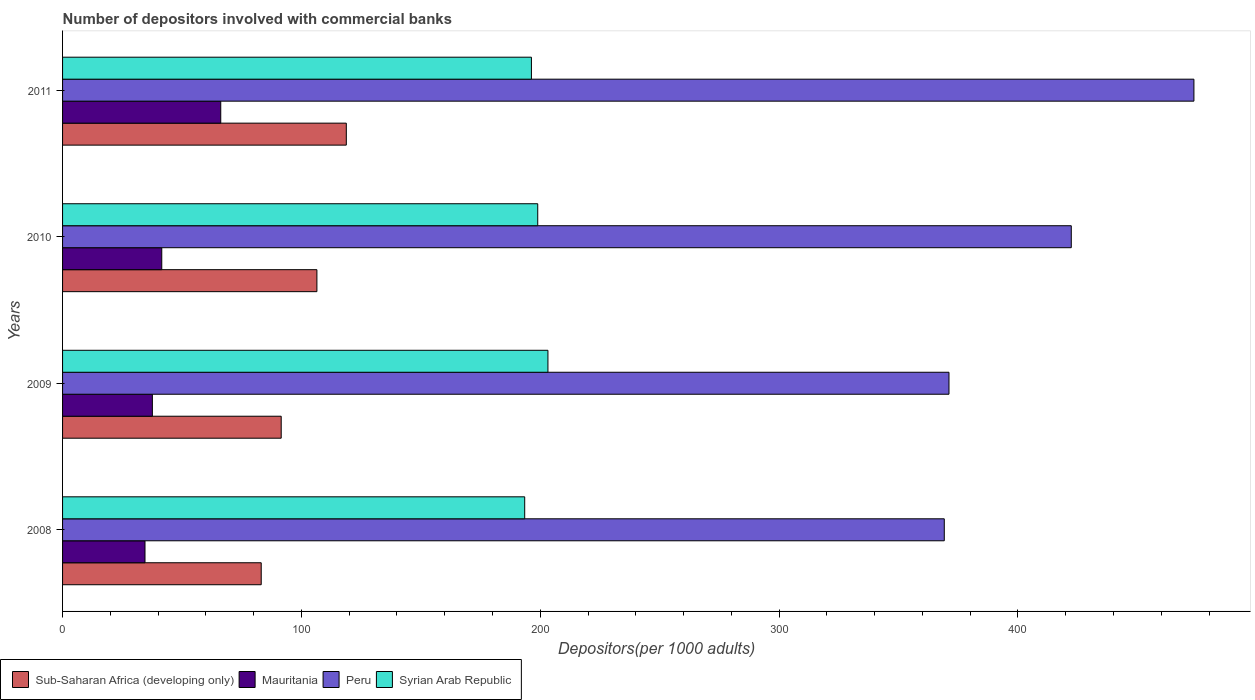In how many cases, is the number of bars for a given year not equal to the number of legend labels?
Ensure brevity in your answer.  0. What is the number of depositors involved with commercial banks in Sub-Saharan Africa (developing only) in 2009?
Make the answer very short. 91.54. Across all years, what is the maximum number of depositors involved with commercial banks in Syrian Arab Republic?
Offer a very short reply. 203.22. Across all years, what is the minimum number of depositors involved with commercial banks in Sub-Saharan Africa (developing only)?
Offer a very short reply. 83.18. In which year was the number of depositors involved with commercial banks in Peru maximum?
Provide a short and direct response. 2011. In which year was the number of depositors involved with commercial banks in Peru minimum?
Provide a succinct answer. 2008. What is the total number of depositors involved with commercial banks in Mauritania in the graph?
Make the answer very short. 179.89. What is the difference between the number of depositors involved with commercial banks in Syrian Arab Republic in 2008 and that in 2010?
Offer a very short reply. -5.46. What is the difference between the number of depositors involved with commercial banks in Mauritania in 2010 and the number of depositors involved with commercial banks in Syrian Arab Republic in 2011?
Make the answer very short. -154.77. What is the average number of depositors involved with commercial banks in Sub-Saharan Africa (developing only) per year?
Provide a short and direct response. 100. In the year 2011, what is the difference between the number of depositors involved with commercial banks in Syrian Arab Republic and number of depositors involved with commercial banks in Sub-Saharan Africa (developing only)?
Make the answer very short. 77.5. What is the ratio of the number of depositors involved with commercial banks in Sub-Saharan Africa (developing only) in 2009 to that in 2011?
Provide a short and direct response. 0.77. Is the difference between the number of depositors involved with commercial banks in Syrian Arab Republic in 2009 and 2011 greater than the difference between the number of depositors involved with commercial banks in Sub-Saharan Africa (developing only) in 2009 and 2011?
Give a very brief answer. Yes. What is the difference between the highest and the second highest number of depositors involved with commercial banks in Syrian Arab Republic?
Your response must be concise. 4.27. What is the difference between the highest and the lowest number of depositors involved with commercial banks in Sub-Saharan Africa (developing only)?
Provide a short and direct response. 35.63. In how many years, is the number of depositors involved with commercial banks in Mauritania greater than the average number of depositors involved with commercial banks in Mauritania taken over all years?
Offer a terse response. 1. Is the sum of the number of depositors involved with commercial banks in Sub-Saharan Africa (developing only) in 2010 and 2011 greater than the maximum number of depositors involved with commercial banks in Peru across all years?
Your answer should be very brief. No. Is it the case that in every year, the sum of the number of depositors involved with commercial banks in Syrian Arab Republic and number of depositors involved with commercial banks in Mauritania is greater than the sum of number of depositors involved with commercial banks in Sub-Saharan Africa (developing only) and number of depositors involved with commercial banks in Peru?
Your answer should be very brief. Yes. What does the 4th bar from the top in 2010 represents?
Ensure brevity in your answer.  Sub-Saharan Africa (developing only). What does the 2nd bar from the bottom in 2008 represents?
Give a very brief answer. Mauritania. Is it the case that in every year, the sum of the number of depositors involved with commercial banks in Sub-Saharan Africa (developing only) and number of depositors involved with commercial banks in Syrian Arab Republic is greater than the number of depositors involved with commercial banks in Peru?
Give a very brief answer. No. What is the difference between two consecutive major ticks on the X-axis?
Offer a terse response. 100. Are the values on the major ticks of X-axis written in scientific E-notation?
Your answer should be very brief. No. Does the graph contain any zero values?
Provide a short and direct response. No. Does the graph contain grids?
Your answer should be compact. No. How many legend labels are there?
Provide a succinct answer. 4. How are the legend labels stacked?
Make the answer very short. Horizontal. What is the title of the graph?
Ensure brevity in your answer.  Number of depositors involved with commercial banks. What is the label or title of the X-axis?
Make the answer very short. Depositors(per 1000 adults). What is the label or title of the Y-axis?
Give a very brief answer. Years. What is the Depositors(per 1000 adults) of Sub-Saharan Africa (developing only) in 2008?
Make the answer very short. 83.18. What is the Depositors(per 1000 adults) of Mauritania in 2008?
Provide a short and direct response. 34.52. What is the Depositors(per 1000 adults) in Peru in 2008?
Keep it short and to the point. 369.17. What is the Depositors(per 1000 adults) of Syrian Arab Republic in 2008?
Ensure brevity in your answer.  193.49. What is the Depositors(per 1000 adults) in Sub-Saharan Africa (developing only) in 2009?
Your answer should be very brief. 91.54. What is the Depositors(per 1000 adults) of Mauritania in 2009?
Offer a terse response. 37.6. What is the Depositors(per 1000 adults) of Peru in 2009?
Make the answer very short. 371.13. What is the Depositors(per 1000 adults) in Syrian Arab Republic in 2009?
Provide a short and direct response. 203.22. What is the Depositors(per 1000 adults) of Sub-Saharan Africa (developing only) in 2010?
Offer a very short reply. 106.49. What is the Depositors(per 1000 adults) of Mauritania in 2010?
Ensure brevity in your answer.  41.54. What is the Depositors(per 1000 adults) in Peru in 2010?
Make the answer very short. 422.34. What is the Depositors(per 1000 adults) of Syrian Arab Republic in 2010?
Offer a very short reply. 198.95. What is the Depositors(per 1000 adults) in Sub-Saharan Africa (developing only) in 2011?
Make the answer very short. 118.8. What is the Depositors(per 1000 adults) of Mauritania in 2011?
Make the answer very short. 66.23. What is the Depositors(per 1000 adults) in Peru in 2011?
Ensure brevity in your answer.  473.69. What is the Depositors(per 1000 adults) of Syrian Arab Republic in 2011?
Provide a succinct answer. 196.31. Across all years, what is the maximum Depositors(per 1000 adults) in Sub-Saharan Africa (developing only)?
Make the answer very short. 118.8. Across all years, what is the maximum Depositors(per 1000 adults) of Mauritania?
Provide a short and direct response. 66.23. Across all years, what is the maximum Depositors(per 1000 adults) in Peru?
Make the answer very short. 473.69. Across all years, what is the maximum Depositors(per 1000 adults) of Syrian Arab Republic?
Give a very brief answer. 203.22. Across all years, what is the minimum Depositors(per 1000 adults) in Sub-Saharan Africa (developing only)?
Provide a succinct answer. 83.18. Across all years, what is the minimum Depositors(per 1000 adults) in Mauritania?
Ensure brevity in your answer.  34.52. Across all years, what is the minimum Depositors(per 1000 adults) in Peru?
Your response must be concise. 369.17. Across all years, what is the minimum Depositors(per 1000 adults) of Syrian Arab Republic?
Your answer should be compact. 193.49. What is the total Depositors(per 1000 adults) in Sub-Saharan Africa (developing only) in the graph?
Provide a succinct answer. 400.01. What is the total Depositors(per 1000 adults) in Mauritania in the graph?
Provide a short and direct response. 179.89. What is the total Depositors(per 1000 adults) in Peru in the graph?
Your answer should be compact. 1636.33. What is the total Depositors(per 1000 adults) in Syrian Arab Republic in the graph?
Ensure brevity in your answer.  791.97. What is the difference between the Depositors(per 1000 adults) of Sub-Saharan Africa (developing only) in 2008 and that in 2009?
Make the answer very short. -8.37. What is the difference between the Depositors(per 1000 adults) of Mauritania in 2008 and that in 2009?
Provide a short and direct response. -3.09. What is the difference between the Depositors(per 1000 adults) in Peru in 2008 and that in 2009?
Keep it short and to the point. -1.97. What is the difference between the Depositors(per 1000 adults) of Syrian Arab Republic in 2008 and that in 2009?
Make the answer very short. -9.73. What is the difference between the Depositors(per 1000 adults) of Sub-Saharan Africa (developing only) in 2008 and that in 2010?
Your answer should be very brief. -23.31. What is the difference between the Depositors(per 1000 adults) of Mauritania in 2008 and that in 2010?
Your response must be concise. -7.02. What is the difference between the Depositors(per 1000 adults) of Peru in 2008 and that in 2010?
Your answer should be compact. -53.18. What is the difference between the Depositors(per 1000 adults) in Syrian Arab Republic in 2008 and that in 2010?
Your answer should be compact. -5.46. What is the difference between the Depositors(per 1000 adults) of Sub-Saharan Africa (developing only) in 2008 and that in 2011?
Your answer should be compact. -35.63. What is the difference between the Depositors(per 1000 adults) in Mauritania in 2008 and that in 2011?
Keep it short and to the point. -31.71. What is the difference between the Depositors(per 1000 adults) in Peru in 2008 and that in 2011?
Ensure brevity in your answer.  -104.52. What is the difference between the Depositors(per 1000 adults) of Syrian Arab Republic in 2008 and that in 2011?
Give a very brief answer. -2.82. What is the difference between the Depositors(per 1000 adults) of Sub-Saharan Africa (developing only) in 2009 and that in 2010?
Keep it short and to the point. -14.95. What is the difference between the Depositors(per 1000 adults) in Mauritania in 2009 and that in 2010?
Make the answer very short. -3.93. What is the difference between the Depositors(per 1000 adults) of Peru in 2009 and that in 2010?
Keep it short and to the point. -51.21. What is the difference between the Depositors(per 1000 adults) of Syrian Arab Republic in 2009 and that in 2010?
Provide a succinct answer. 4.27. What is the difference between the Depositors(per 1000 adults) of Sub-Saharan Africa (developing only) in 2009 and that in 2011?
Ensure brevity in your answer.  -27.26. What is the difference between the Depositors(per 1000 adults) in Mauritania in 2009 and that in 2011?
Provide a short and direct response. -28.63. What is the difference between the Depositors(per 1000 adults) of Peru in 2009 and that in 2011?
Your answer should be compact. -102.56. What is the difference between the Depositors(per 1000 adults) of Syrian Arab Republic in 2009 and that in 2011?
Give a very brief answer. 6.91. What is the difference between the Depositors(per 1000 adults) in Sub-Saharan Africa (developing only) in 2010 and that in 2011?
Your answer should be compact. -12.31. What is the difference between the Depositors(per 1000 adults) of Mauritania in 2010 and that in 2011?
Your response must be concise. -24.69. What is the difference between the Depositors(per 1000 adults) of Peru in 2010 and that in 2011?
Give a very brief answer. -51.35. What is the difference between the Depositors(per 1000 adults) in Syrian Arab Republic in 2010 and that in 2011?
Your answer should be very brief. 2.64. What is the difference between the Depositors(per 1000 adults) in Sub-Saharan Africa (developing only) in 2008 and the Depositors(per 1000 adults) in Mauritania in 2009?
Offer a very short reply. 45.57. What is the difference between the Depositors(per 1000 adults) in Sub-Saharan Africa (developing only) in 2008 and the Depositors(per 1000 adults) in Peru in 2009?
Offer a terse response. -287.96. What is the difference between the Depositors(per 1000 adults) of Sub-Saharan Africa (developing only) in 2008 and the Depositors(per 1000 adults) of Syrian Arab Republic in 2009?
Your response must be concise. -120.04. What is the difference between the Depositors(per 1000 adults) in Mauritania in 2008 and the Depositors(per 1000 adults) in Peru in 2009?
Make the answer very short. -336.62. What is the difference between the Depositors(per 1000 adults) in Mauritania in 2008 and the Depositors(per 1000 adults) in Syrian Arab Republic in 2009?
Ensure brevity in your answer.  -168.7. What is the difference between the Depositors(per 1000 adults) of Peru in 2008 and the Depositors(per 1000 adults) of Syrian Arab Republic in 2009?
Ensure brevity in your answer.  165.95. What is the difference between the Depositors(per 1000 adults) in Sub-Saharan Africa (developing only) in 2008 and the Depositors(per 1000 adults) in Mauritania in 2010?
Provide a succinct answer. 41.64. What is the difference between the Depositors(per 1000 adults) in Sub-Saharan Africa (developing only) in 2008 and the Depositors(per 1000 adults) in Peru in 2010?
Your answer should be very brief. -339.17. What is the difference between the Depositors(per 1000 adults) in Sub-Saharan Africa (developing only) in 2008 and the Depositors(per 1000 adults) in Syrian Arab Republic in 2010?
Ensure brevity in your answer.  -115.77. What is the difference between the Depositors(per 1000 adults) of Mauritania in 2008 and the Depositors(per 1000 adults) of Peru in 2010?
Keep it short and to the point. -387.83. What is the difference between the Depositors(per 1000 adults) in Mauritania in 2008 and the Depositors(per 1000 adults) in Syrian Arab Republic in 2010?
Provide a succinct answer. -164.43. What is the difference between the Depositors(per 1000 adults) in Peru in 2008 and the Depositors(per 1000 adults) in Syrian Arab Republic in 2010?
Offer a terse response. 170.22. What is the difference between the Depositors(per 1000 adults) of Sub-Saharan Africa (developing only) in 2008 and the Depositors(per 1000 adults) of Mauritania in 2011?
Your answer should be very brief. 16.95. What is the difference between the Depositors(per 1000 adults) in Sub-Saharan Africa (developing only) in 2008 and the Depositors(per 1000 adults) in Peru in 2011?
Ensure brevity in your answer.  -390.51. What is the difference between the Depositors(per 1000 adults) of Sub-Saharan Africa (developing only) in 2008 and the Depositors(per 1000 adults) of Syrian Arab Republic in 2011?
Your answer should be very brief. -113.13. What is the difference between the Depositors(per 1000 adults) in Mauritania in 2008 and the Depositors(per 1000 adults) in Peru in 2011?
Provide a short and direct response. -439.17. What is the difference between the Depositors(per 1000 adults) of Mauritania in 2008 and the Depositors(per 1000 adults) of Syrian Arab Republic in 2011?
Your response must be concise. -161.79. What is the difference between the Depositors(per 1000 adults) of Peru in 2008 and the Depositors(per 1000 adults) of Syrian Arab Republic in 2011?
Offer a terse response. 172.86. What is the difference between the Depositors(per 1000 adults) in Sub-Saharan Africa (developing only) in 2009 and the Depositors(per 1000 adults) in Mauritania in 2010?
Keep it short and to the point. 50.01. What is the difference between the Depositors(per 1000 adults) in Sub-Saharan Africa (developing only) in 2009 and the Depositors(per 1000 adults) in Peru in 2010?
Ensure brevity in your answer.  -330.8. What is the difference between the Depositors(per 1000 adults) of Sub-Saharan Africa (developing only) in 2009 and the Depositors(per 1000 adults) of Syrian Arab Republic in 2010?
Offer a very short reply. -107.4. What is the difference between the Depositors(per 1000 adults) in Mauritania in 2009 and the Depositors(per 1000 adults) in Peru in 2010?
Give a very brief answer. -384.74. What is the difference between the Depositors(per 1000 adults) in Mauritania in 2009 and the Depositors(per 1000 adults) in Syrian Arab Republic in 2010?
Provide a succinct answer. -161.34. What is the difference between the Depositors(per 1000 adults) of Peru in 2009 and the Depositors(per 1000 adults) of Syrian Arab Republic in 2010?
Your answer should be compact. 172.19. What is the difference between the Depositors(per 1000 adults) in Sub-Saharan Africa (developing only) in 2009 and the Depositors(per 1000 adults) in Mauritania in 2011?
Your answer should be compact. 25.31. What is the difference between the Depositors(per 1000 adults) in Sub-Saharan Africa (developing only) in 2009 and the Depositors(per 1000 adults) in Peru in 2011?
Give a very brief answer. -382.15. What is the difference between the Depositors(per 1000 adults) of Sub-Saharan Africa (developing only) in 2009 and the Depositors(per 1000 adults) of Syrian Arab Republic in 2011?
Keep it short and to the point. -104.77. What is the difference between the Depositors(per 1000 adults) in Mauritania in 2009 and the Depositors(per 1000 adults) in Peru in 2011?
Provide a short and direct response. -436.09. What is the difference between the Depositors(per 1000 adults) of Mauritania in 2009 and the Depositors(per 1000 adults) of Syrian Arab Republic in 2011?
Ensure brevity in your answer.  -158.71. What is the difference between the Depositors(per 1000 adults) of Peru in 2009 and the Depositors(per 1000 adults) of Syrian Arab Republic in 2011?
Your answer should be very brief. 174.82. What is the difference between the Depositors(per 1000 adults) of Sub-Saharan Africa (developing only) in 2010 and the Depositors(per 1000 adults) of Mauritania in 2011?
Give a very brief answer. 40.26. What is the difference between the Depositors(per 1000 adults) in Sub-Saharan Africa (developing only) in 2010 and the Depositors(per 1000 adults) in Peru in 2011?
Your response must be concise. -367.2. What is the difference between the Depositors(per 1000 adults) in Sub-Saharan Africa (developing only) in 2010 and the Depositors(per 1000 adults) in Syrian Arab Republic in 2011?
Offer a very short reply. -89.82. What is the difference between the Depositors(per 1000 adults) of Mauritania in 2010 and the Depositors(per 1000 adults) of Peru in 2011?
Your answer should be very brief. -432.15. What is the difference between the Depositors(per 1000 adults) in Mauritania in 2010 and the Depositors(per 1000 adults) in Syrian Arab Republic in 2011?
Your answer should be compact. -154.77. What is the difference between the Depositors(per 1000 adults) in Peru in 2010 and the Depositors(per 1000 adults) in Syrian Arab Republic in 2011?
Ensure brevity in your answer.  226.03. What is the average Depositors(per 1000 adults) of Sub-Saharan Africa (developing only) per year?
Offer a terse response. 100. What is the average Depositors(per 1000 adults) of Mauritania per year?
Offer a terse response. 44.97. What is the average Depositors(per 1000 adults) in Peru per year?
Your answer should be compact. 409.08. What is the average Depositors(per 1000 adults) of Syrian Arab Republic per year?
Offer a terse response. 197.99. In the year 2008, what is the difference between the Depositors(per 1000 adults) in Sub-Saharan Africa (developing only) and Depositors(per 1000 adults) in Mauritania?
Offer a very short reply. 48.66. In the year 2008, what is the difference between the Depositors(per 1000 adults) in Sub-Saharan Africa (developing only) and Depositors(per 1000 adults) in Peru?
Ensure brevity in your answer.  -285.99. In the year 2008, what is the difference between the Depositors(per 1000 adults) in Sub-Saharan Africa (developing only) and Depositors(per 1000 adults) in Syrian Arab Republic?
Offer a very short reply. -110.31. In the year 2008, what is the difference between the Depositors(per 1000 adults) of Mauritania and Depositors(per 1000 adults) of Peru?
Provide a short and direct response. -334.65. In the year 2008, what is the difference between the Depositors(per 1000 adults) in Mauritania and Depositors(per 1000 adults) in Syrian Arab Republic?
Ensure brevity in your answer.  -158.97. In the year 2008, what is the difference between the Depositors(per 1000 adults) of Peru and Depositors(per 1000 adults) of Syrian Arab Republic?
Keep it short and to the point. 175.68. In the year 2009, what is the difference between the Depositors(per 1000 adults) in Sub-Saharan Africa (developing only) and Depositors(per 1000 adults) in Mauritania?
Offer a terse response. 53.94. In the year 2009, what is the difference between the Depositors(per 1000 adults) in Sub-Saharan Africa (developing only) and Depositors(per 1000 adults) in Peru?
Provide a succinct answer. -279.59. In the year 2009, what is the difference between the Depositors(per 1000 adults) of Sub-Saharan Africa (developing only) and Depositors(per 1000 adults) of Syrian Arab Republic?
Ensure brevity in your answer.  -111.68. In the year 2009, what is the difference between the Depositors(per 1000 adults) in Mauritania and Depositors(per 1000 adults) in Peru?
Give a very brief answer. -333.53. In the year 2009, what is the difference between the Depositors(per 1000 adults) of Mauritania and Depositors(per 1000 adults) of Syrian Arab Republic?
Give a very brief answer. -165.62. In the year 2009, what is the difference between the Depositors(per 1000 adults) in Peru and Depositors(per 1000 adults) in Syrian Arab Republic?
Offer a very short reply. 167.91. In the year 2010, what is the difference between the Depositors(per 1000 adults) of Sub-Saharan Africa (developing only) and Depositors(per 1000 adults) of Mauritania?
Keep it short and to the point. 64.95. In the year 2010, what is the difference between the Depositors(per 1000 adults) of Sub-Saharan Africa (developing only) and Depositors(per 1000 adults) of Peru?
Keep it short and to the point. -315.85. In the year 2010, what is the difference between the Depositors(per 1000 adults) in Sub-Saharan Africa (developing only) and Depositors(per 1000 adults) in Syrian Arab Republic?
Provide a short and direct response. -92.46. In the year 2010, what is the difference between the Depositors(per 1000 adults) in Mauritania and Depositors(per 1000 adults) in Peru?
Offer a terse response. -380.81. In the year 2010, what is the difference between the Depositors(per 1000 adults) of Mauritania and Depositors(per 1000 adults) of Syrian Arab Republic?
Make the answer very short. -157.41. In the year 2010, what is the difference between the Depositors(per 1000 adults) in Peru and Depositors(per 1000 adults) in Syrian Arab Republic?
Provide a short and direct response. 223.4. In the year 2011, what is the difference between the Depositors(per 1000 adults) in Sub-Saharan Africa (developing only) and Depositors(per 1000 adults) in Mauritania?
Provide a short and direct response. 52.57. In the year 2011, what is the difference between the Depositors(per 1000 adults) in Sub-Saharan Africa (developing only) and Depositors(per 1000 adults) in Peru?
Your response must be concise. -354.89. In the year 2011, what is the difference between the Depositors(per 1000 adults) in Sub-Saharan Africa (developing only) and Depositors(per 1000 adults) in Syrian Arab Republic?
Make the answer very short. -77.5. In the year 2011, what is the difference between the Depositors(per 1000 adults) in Mauritania and Depositors(per 1000 adults) in Peru?
Keep it short and to the point. -407.46. In the year 2011, what is the difference between the Depositors(per 1000 adults) in Mauritania and Depositors(per 1000 adults) in Syrian Arab Republic?
Offer a terse response. -130.08. In the year 2011, what is the difference between the Depositors(per 1000 adults) of Peru and Depositors(per 1000 adults) of Syrian Arab Republic?
Your answer should be compact. 277.38. What is the ratio of the Depositors(per 1000 adults) in Sub-Saharan Africa (developing only) in 2008 to that in 2009?
Provide a short and direct response. 0.91. What is the ratio of the Depositors(per 1000 adults) in Mauritania in 2008 to that in 2009?
Make the answer very short. 0.92. What is the ratio of the Depositors(per 1000 adults) of Syrian Arab Republic in 2008 to that in 2009?
Your answer should be compact. 0.95. What is the ratio of the Depositors(per 1000 adults) of Sub-Saharan Africa (developing only) in 2008 to that in 2010?
Your answer should be compact. 0.78. What is the ratio of the Depositors(per 1000 adults) of Mauritania in 2008 to that in 2010?
Your response must be concise. 0.83. What is the ratio of the Depositors(per 1000 adults) in Peru in 2008 to that in 2010?
Provide a succinct answer. 0.87. What is the ratio of the Depositors(per 1000 adults) in Syrian Arab Republic in 2008 to that in 2010?
Provide a short and direct response. 0.97. What is the ratio of the Depositors(per 1000 adults) of Sub-Saharan Africa (developing only) in 2008 to that in 2011?
Provide a short and direct response. 0.7. What is the ratio of the Depositors(per 1000 adults) of Mauritania in 2008 to that in 2011?
Keep it short and to the point. 0.52. What is the ratio of the Depositors(per 1000 adults) in Peru in 2008 to that in 2011?
Provide a succinct answer. 0.78. What is the ratio of the Depositors(per 1000 adults) of Syrian Arab Republic in 2008 to that in 2011?
Give a very brief answer. 0.99. What is the ratio of the Depositors(per 1000 adults) of Sub-Saharan Africa (developing only) in 2009 to that in 2010?
Your answer should be compact. 0.86. What is the ratio of the Depositors(per 1000 adults) of Mauritania in 2009 to that in 2010?
Make the answer very short. 0.91. What is the ratio of the Depositors(per 1000 adults) of Peru in 2009 to that in 2010?
Your answer should be compact. 0.88. What is the ratio of the Depositors(per 1000 adults) in Syrian Arab Republic in 2009 to that in 2010?
Keep it short and to the point. 1.02. What is the ratio of the Depositors(per 1000 adults) in Sub-Saharan Africa (developing only) in 2009 to that in 2011?
Give a very brief answer. 0.77. What is the ratio of the Depositors(per 1000 adults) of Mauritania in 2009 to that in 2011?
Provide a succinct answer. 0.57. What is the ratio of the Depositors(per 1000 adults) of Peru in 2009 to that in 2011?
Your answer should be very brief. 0.78. What is the ratio of the Depositors(per 1000 adults) of Syrian Arab Republic in 2009 to that in 2011?
Give a very brief answer. 1.04. What is the ratio of the Depositors(per 1000 adults) in Sub-Saharan Africa (developing only) in 2010 to that in 2011?
Your answer should be compact. 0.9. What is the ratio of the Depositors(per 1000 adults) of Mauritania in 2010 to that in 2011?
Provide a succinct answer. 0.63. What is the ratio of the Depositors(per 1000 adults) in Peru in 2010 to that in 2011?
Your response must be concise. 0.89. What is the ratio of the Depositors(per 1000 adults) in Syrian Arab Republic in 2010 to that in 2011?
Ensure brevity in your answer.  1.01. What is the difference between the highest and the second highest Depositors(per 1000 adults) of Sub-Saharan Africa (developing only)?
Give a very brief answer. 12.31. What is the difference between the highest and the second highest Depositors(per 1000 adults) in Mauritania?
Give a very brief answer. 24.69. What is the difference between the highest and the second highest Depositors(per 1000 adults) in Peru?
Provide a succinct answer. 51.35. What is the difference between the highest and the second highest Depositors(per 1000 adults) in Syrian Arab Republic?
Ensure brevity in your answer.  4.27. What is the difference between the highest and the lowest Depositors(per 1000 adults) in Sub-Saharan Africa (developing only)?
Provide a short and direct response. 35.63. What is the difference between the highest and the lowest Depositors(per 1000 adults) of Mauritania?
Give a very brief answer. 31.71. What is the difference between the highest and the lowest Depositors(per 1000 adults) in Peru?
Provide a succinct answer. 104.52. What is the difference between the highest and the lowest Depositors(per 1000 adults) of Syrian Arab Republic?
Your response must be concise. 9.73. 